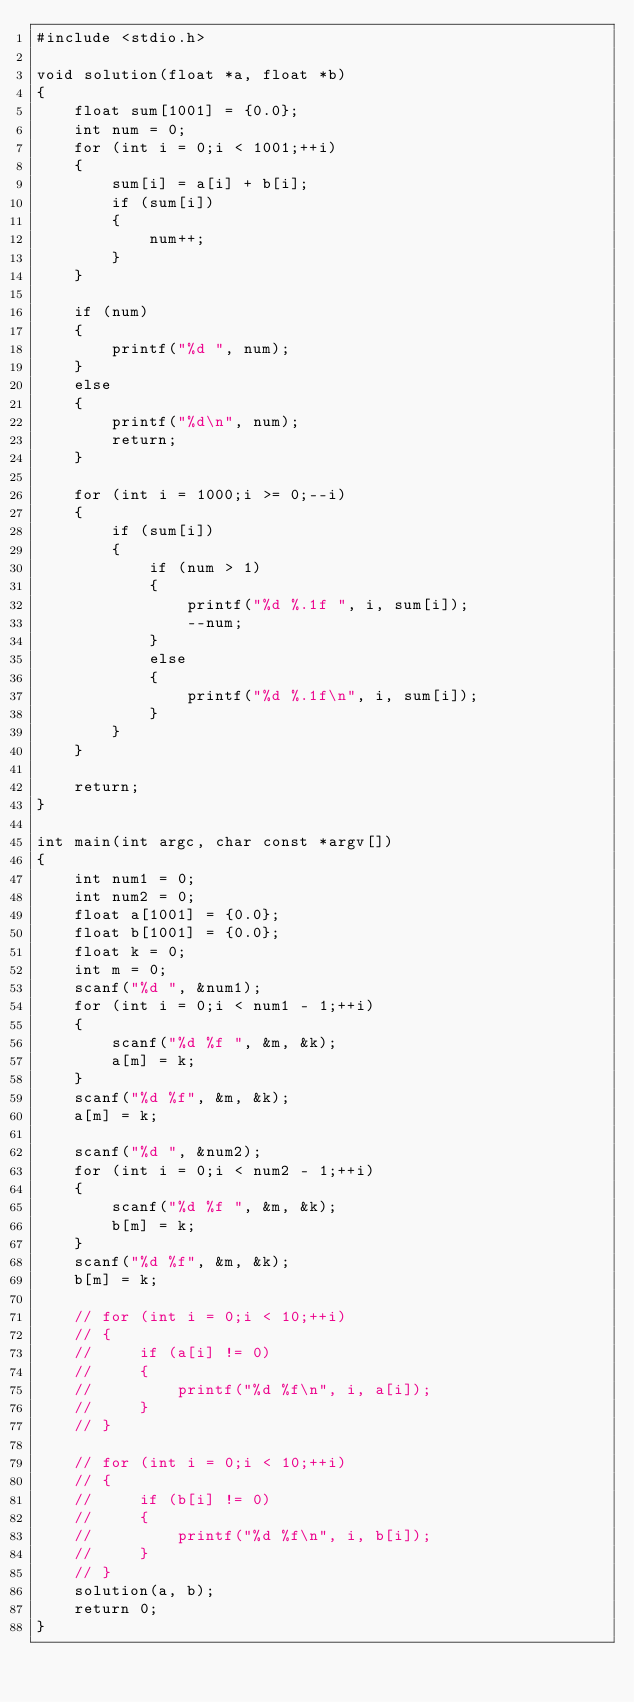Convert code to text. <code><loc_0><loc_0><loc_500><loc_500><_C_>#include <stdio.h>

void solution(float *a, float *b)
{
    float sum[1001] = {0.0};
    int num = 0;
    for (int i = 0;i < 1001;++i)
    {
        sum[i] = a[i] + b[i];
        if (sum[i])
        {
            num++;
        }
    }

    if (num)
    {
        printf("%d ", num);
    }
    else
    {
        printf("%d\n", num);
        return;
    }

    for (int i = 1000;i >= 0;--i)
    {
        if (sum[i])
        {
            if (num > 1)
            {
                printf("%d %.1f ", i, sum[i]);
                --num;
            }
            else
            {
                printf("%d %.1f\n", i, sum[i]);
            }
        }
    }

    return;
}

int main(int argc, char const *argv[])
{
    int num1 = 0;
    int num2 = 0;
    float a[1001] = {0.0};
    float b[1001] = {0.0};
    float k = 0;
    int m = 0;
    scanf("%d ", &num1);
    for (int i = 0;i < num1 - 1;++i)
    {
        scanf("%d %f ", &m, &k);
        a[m] = k;
    }
    scanf("%d %f", &m, &k);
    a[m] = k;

    scanf("%d ", &num2);
    for (int i = 0;i < num2 - 1;++i)
    {
        scanf("%d %f ", &m, &k);
        b[m] = k;
    }
    scanf("%d %f", &m, &k);
    b[m] = k;

    // for (int i = 0;i < 10;++i)
    // {
    //     if (a[i] != 0)
    //     {
    //         printf("%d %f\n", i, a[i]);
    //     }
    // }

    // for (int i = 0;i < 10;++i)
    // {
    //     if (b[i] != 0)
    //     {
    //         printf("%d %f\n", i, b[i]);
    //     }
    // }
    solution(a, b);
    return 0;
}
</code> 